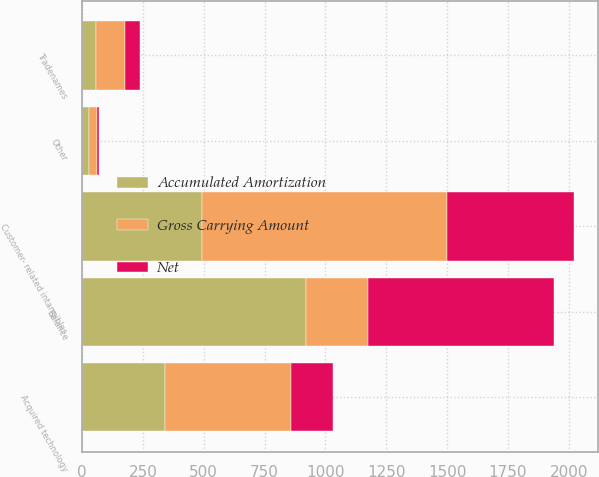Convert chart to OTSL. <chart><loc_0><loc_0><loc_500><loc_500><stacked_bar_chart><ecel><fcel>Acquired technology<fcel>Customer- related intangibles<fcel>Tradenames<fcel>Other<fcel>Balance<nl><fcel>Gross Carrying Amount<fcel>516<fcel>1010<fcel>120<fcel>34<fcel>258<nl><fcel>Accumulated Amortization<fcel>342<fcel>491<fcel>57<fcel>29<fcel>919<nl><fcel>Net<fcel>174<fcel>519<fcel>63<fcel>5<fcel>761<nl></chart> 